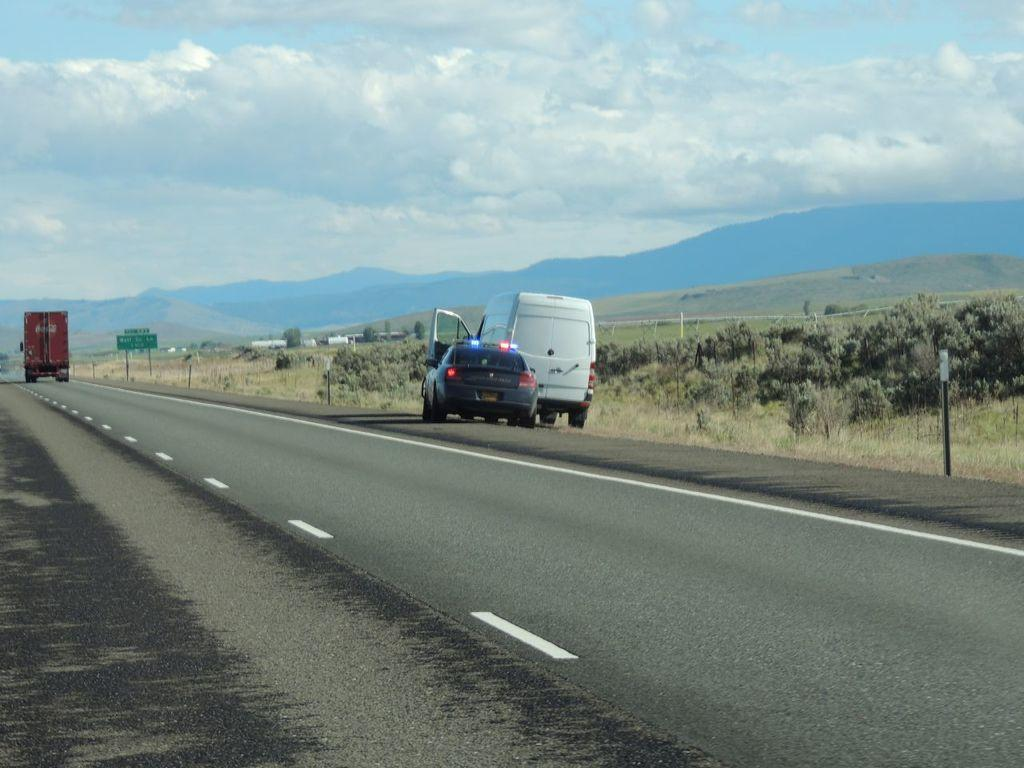What is the main feature of the image? There is a road in the image. What is happening on the road? Vehicles are present on the road. What can be seen in the background of the image? There are trees, hills, and the sky visible in the background of the image. Is there any other object or structure in the image? Yes, there is a board in the image. What type of coil is being used to power the fan in the image? There is no fan or coil present in the image. What brand of jeans is the person wearing in the image? There is no person or jeans present in the image. 